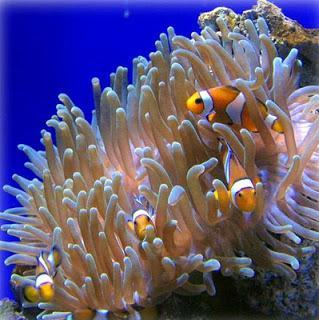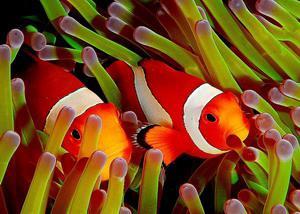The first image is the image on the left, the second image is the image on the right. Given the left and right images, does the statement "An image shows exactly one clownfish swimming near neutral-colored anemone tendrils." hold true? Answer yes or no. No. The first image is the image on the left, the second image is the image on the right. Evaluate the accuracy of this statement regarding the images: "The right image contains exactly one clown fish.". Is it true? Answer yes or no. No. 